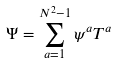Convert formula to latex. <formula><loc_0><loc_0><loc_500><loc_500>\Psi = \sum _ { a = 1 } ^ { N ^ { 2 } - 1 } \psi ^ { a } T ^ { a }</formula> 